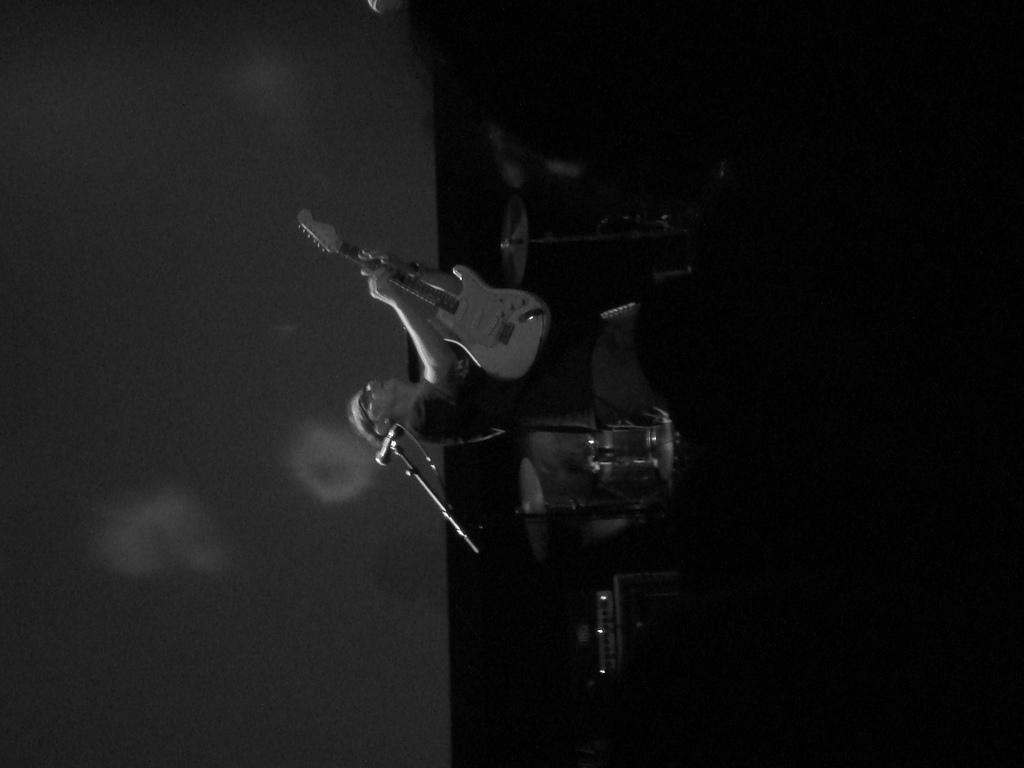What is the main subject of the image? The main subject of the image is a person. What is the person holding in the image? The person is holding a guitar. What is the color scheme of the image? The image is black and white. What is the plot of the story unfolding in the image? There is no story or plot depicted in the image; it simply shows a person holding a guitar. Is the person in the image sleeping or playing the guitar? The image does not show the person sleeping; they are holding a guitar, but their actions are not explicitly shown. --- 